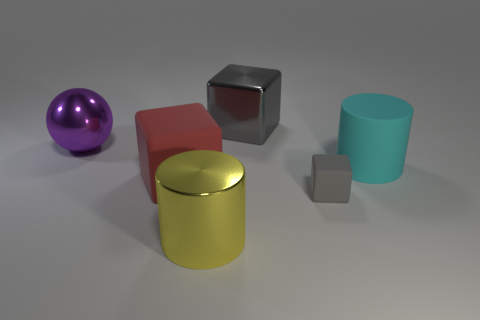Are there any brown matte cylinders of the same size as the red rubber object?
Give a very brief answer. No. Is the number of tiny gray blocks that are in front of the tiny matte thing less than the number of large cylinders?
Ensure brevity in your answer.  Yes. The gray thing that is right of the large cube that is behind the cube to the left of the large yellow metallic object is made of what material?
Provide a succinct answer. Rubber. Are there more cyan rubber cylinders that are behind the cyan object than things behind the big sphere?
Your answer should be very brief. No. How many metal things are yellow cylinders or large red things?
Offer a terse response. 1. What is the material of the object right of the tiny matte thing?
Give a very brief answer. Rubber. What number of things are either cyan cylinders or big matte objects in front of the cyan thing?
Ensure brevity in your answer.  2. What is the shape of the cyan thing that is the same size as the metal cylinder?
Make the answer very short. Cylinder. How many big balls have the same color as the big rubber cylinder?
Provide a short and direct response. 0. Is the material of the large cube that is behind the large purple ball the same as the ball?
Provide a short and direct response. Yes. 